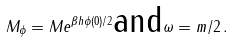Convert formula to latex. <formula><loc_0><loc_0><loc_500><loc_500>M _ { \phi } = M e ^ { \beta h \phi ( 0 ) / 2 } \text {and} \omega = m / 2 \, .</formula> 